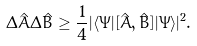<formula> <loc_0><loc_0><loc_500><loc_500>\Delta \hat { A } \Delta \hat { B } \geq \frac { 1 } { 4 } | \langle \Psi | [ \hat { A } , \hat { B } ] | \Psi \rangle | ^ { 2 } .</formula> 